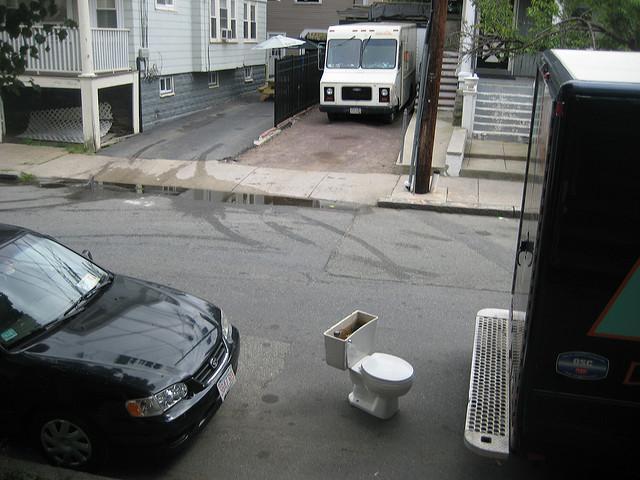What is between the car and the cube truck?
From the following four choices, select the correct answer to address the question.
Options: Mirror, toilet, sink, tub. Toilet. 